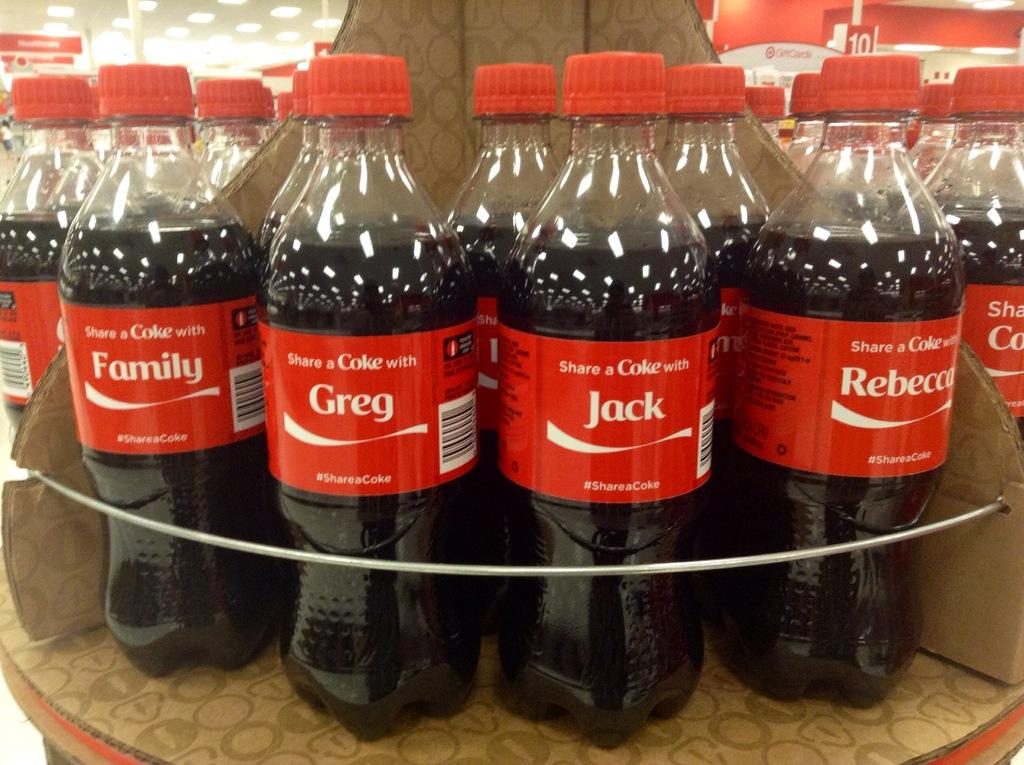Provide a one-sentence caption for the provided image. bottles of Coke with people's names like Jack and Greg. 